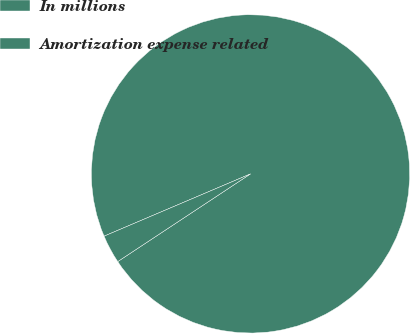Convert chart. <chart><loc_0><loc_0><loc_500><loc_500><pie_chart><fcel>In millions<fcel>Amortization expense related<nl><fcel>97.11%<fcel>2.89%<nl></chart> 